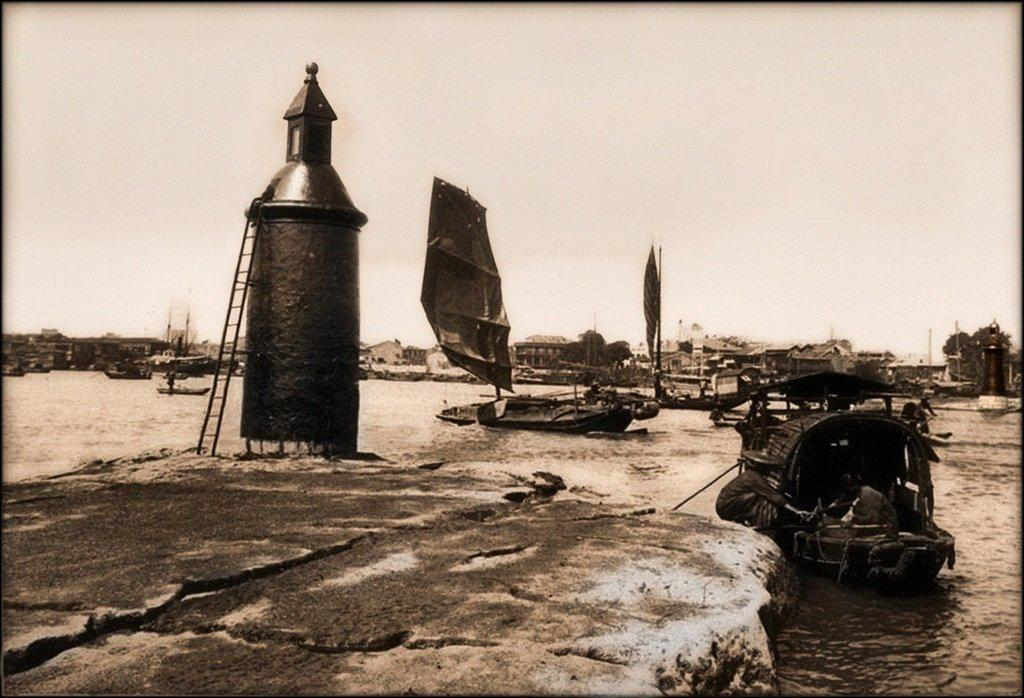What is the primary element in the image? There is water in the image. What is on the water in the image? There are boats on the water. What structure can be seen in the image? There is a tank in the image. What can be seen in the background of the image? There are buildings, trees, and the sky visible in the background of the image. What is present at the bottom of the image? There is a rock at the bottom of the image. What type of sign is visible on the rock at the bottom of the image? There is no sign visible on the rock at the bottom of the image. Who is the creator of the water in the image? The image is a photograph or illustration, and the water is a natural element, so there is no specific creator for the water in the image. 